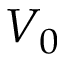<formula> <loc_0><loc_0><loc_500><loc_500>V _ { 0 }</formula> 